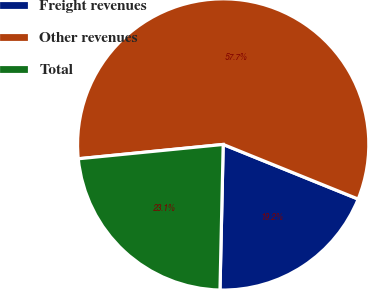<chart> <loc_0><loc_0><loc_500><loc_500><pie_chart><fcel>Freight revenues<fcel>Other revenues<fcel>Total<nl><fcel>19.23%<fcel>57.69%<fcel>23.08%<nl></chart> 